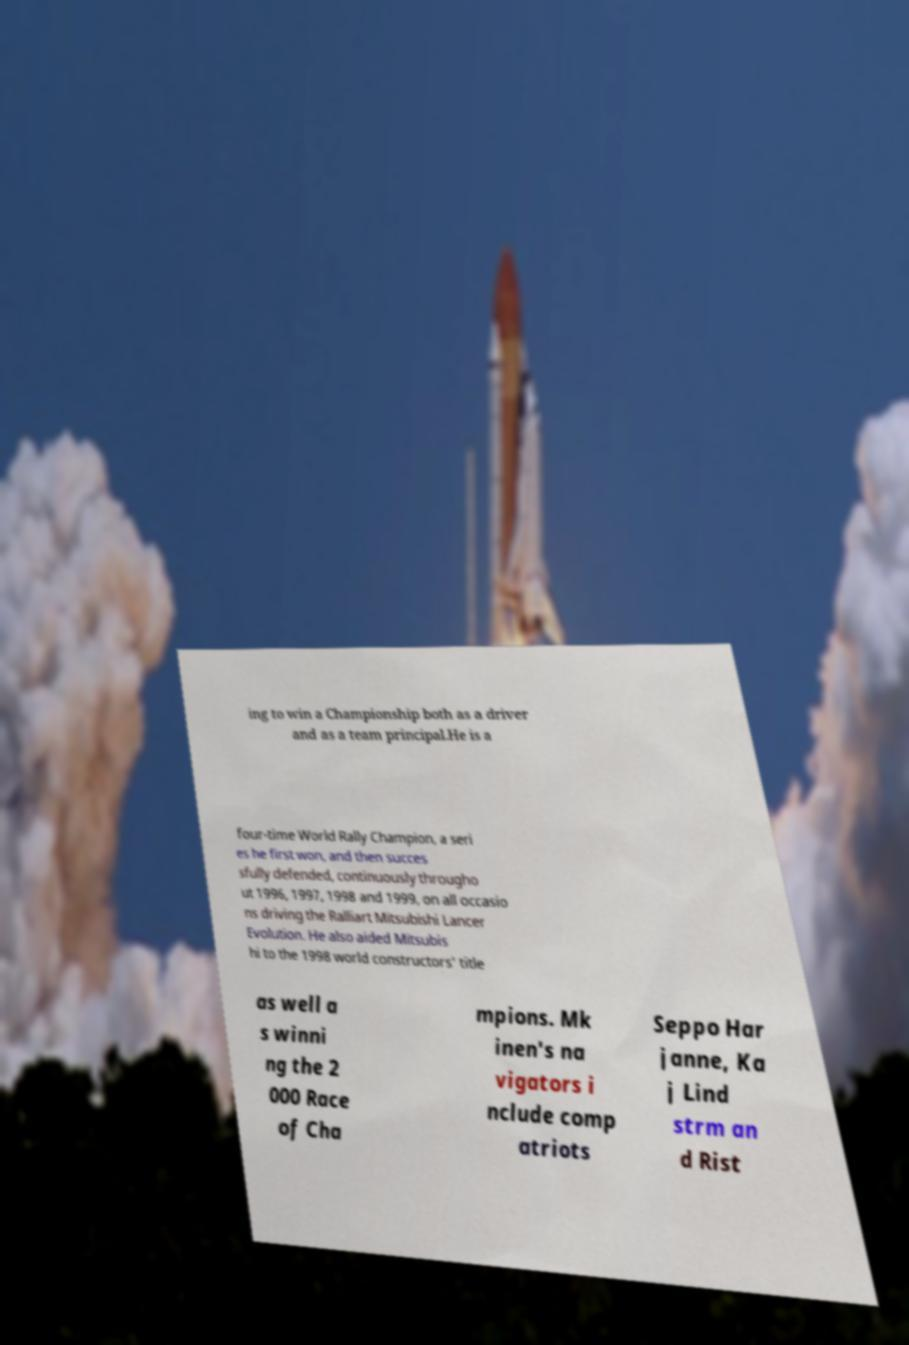Please read and relay the text visible in this image. What does it say? ing to win a Championship both as a driver and as a team principal.He is a four-time World Rally Champion, a seri es he first won, and then succes sfully defended, continuously througho ut 1996, 1997, 1998 and 1999, on all occasio ns driving the Ralliart Mitsubishi Lancer Evolution. He also aided Mitsubis hi to the 1998 world constructors' title as well a s winni ng the 2 000 Race of Cha mpions. Mk inen's na vigators i nclude comp atriots Seppo Har janne, Ka j Lind strm an d Rist 